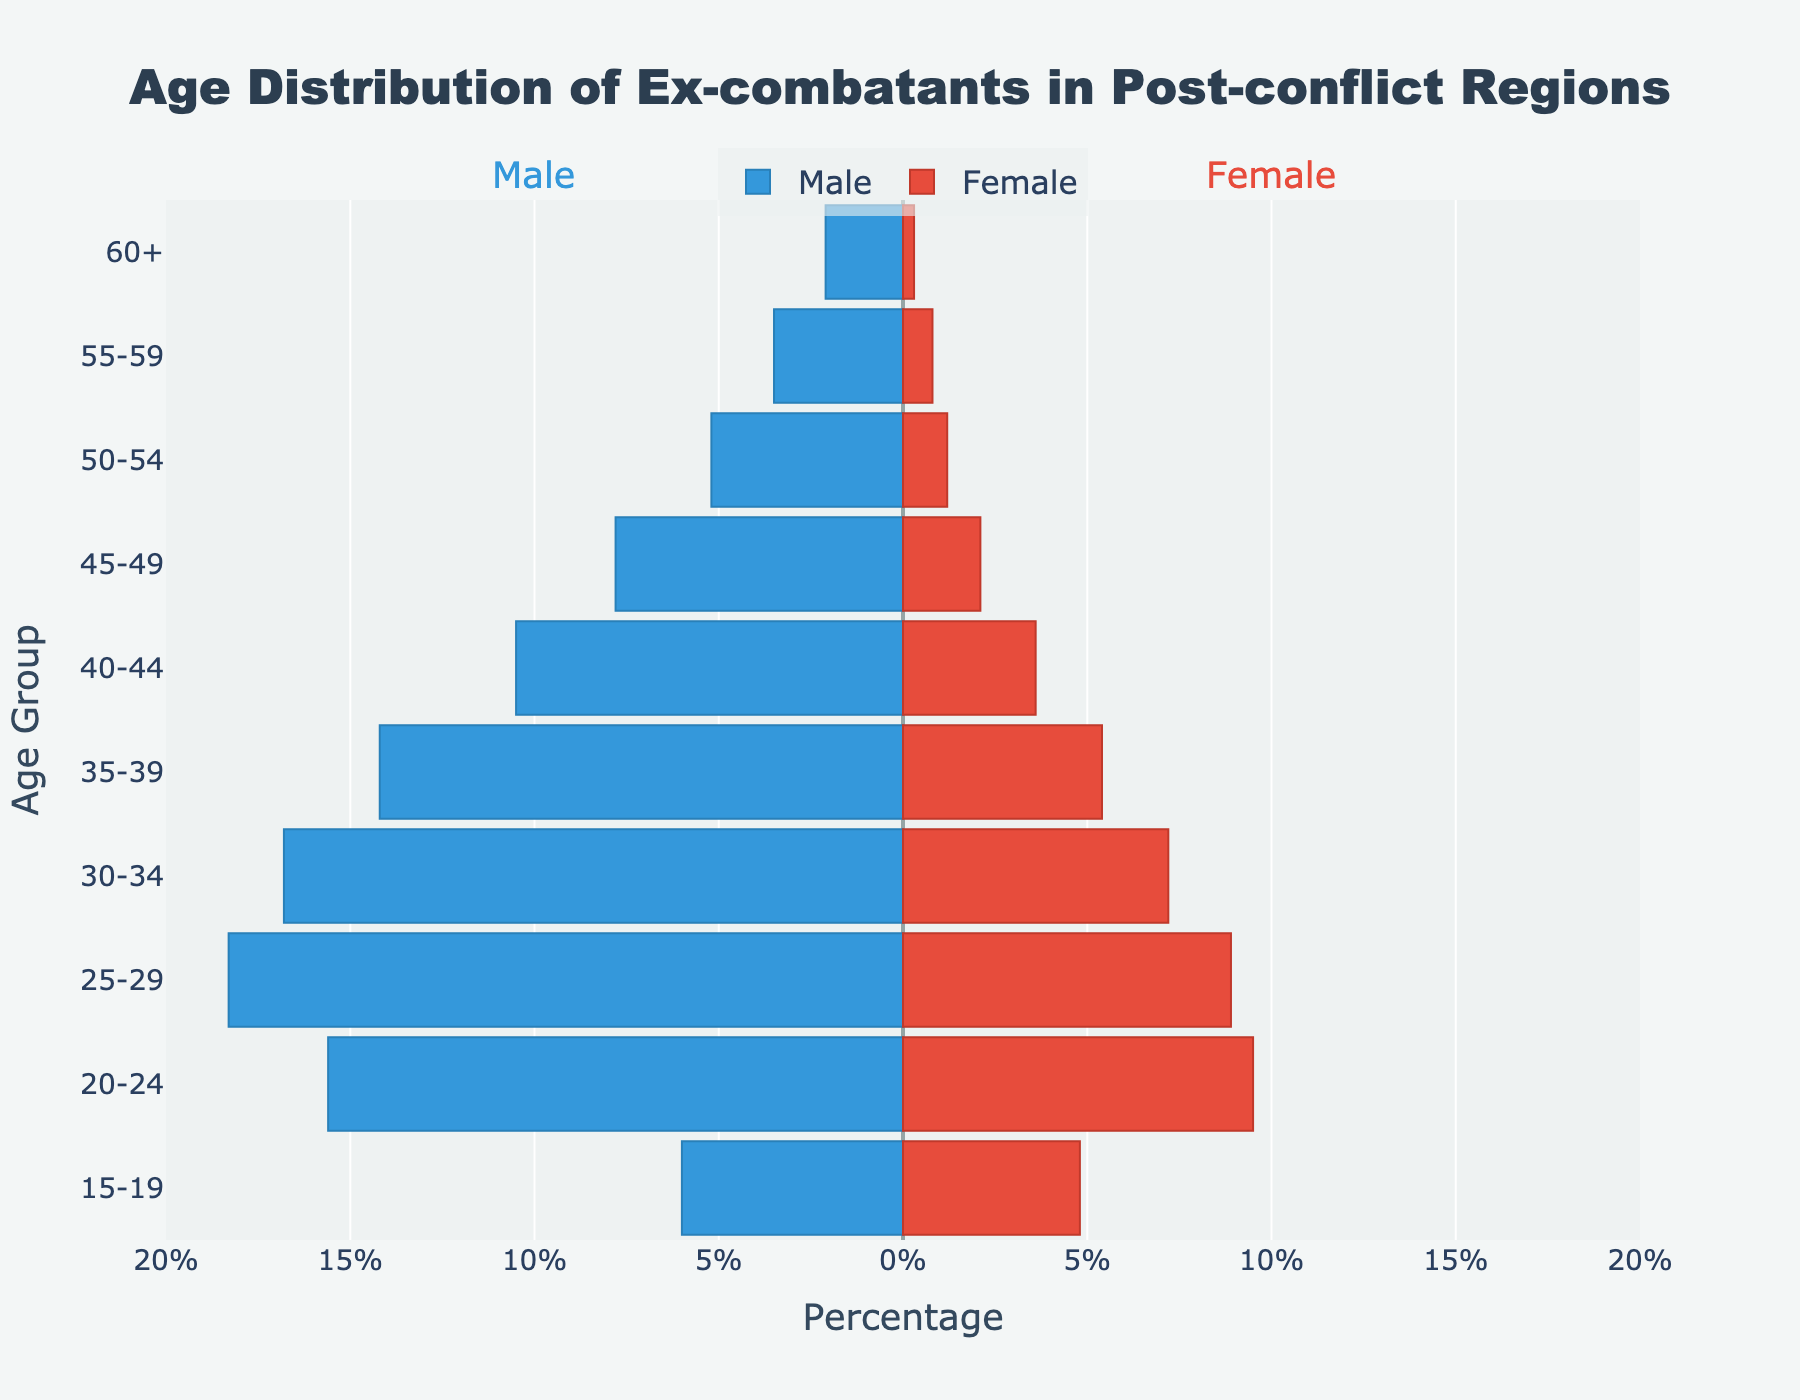what is the age group with the highest percentage of male ex-combatants? To find this, look at the male bars extending to the left. The longest bar represents the highest percentage. The age group 25-29 has the longest bar.
Answer: 25-29 what is the percentage of female ex-combatants in the age group 20-24? Look at the bar corresponding to the female ex-combatants for the age group 20-24. The value next to this bar is 9.5%.
Answer: 9.5% how does the percentage of male ex-combatants in the age group 40-44 compare to the percentage in the age group 30-34? Compare the length of the male bars for the age groups 40-44 and 30-34. The 40-44 age group has 10.5% while the 30-34 age group has 16.8%. The percentage is lower in the 40-44 age group.
Answer: lower in 40-44 which gender has a higher representation in the age group 55-59? Compare the lengths of the male and female bars for the age group 55-59. The male bar (3.5%) is longer than the female bar (0.8%). Therefore, males have a higher representation.
Answer: male what is the total percentage of ex-combatants (both male and female) in the age group 45-49? Add the male and female percentages within the age group 45-49. The male percentage is 7.8% and the female percentage is 2.1%. Therefore, the total is 7.8% + 2.1% = 9.9%.
Answer: 9.9% how does the percentage of female ex-combatants aged 30-34 compare to those aged 50-54? Compare the lengths of the female bars for age groups 30-34 and 50-54. The 30-34 age group has 7.2% and the 50-54 age group has 1.2%. So, the percentage is higher in the 30-34 age group.
Answer: higher in 30-34 which age group has the smallest difference in male and female percentages? Calculate the absolute differences between male and female percentages for each age group. The smallest difference is observed where the difference is minimal. Age group 20-24 has the smallest difference of 6.1% (15.6% - 9.5%).
Answer: 20-24 what is the total percentage of male ex-combatants aged 35-49? Add the male percentages for the age groups within the range 35-49, which are 35-39 (14.2%), 40-44 (10.5%), and 45-49 (7.8%). Therefore, the total is 14.2% + 10.5% + 7.8% = 32.5%.
Answer: 32.5% do both genders have the same percentage distribution in any age group? Check each age group's male and female bar lengths to see if any match. No age group has the same percentage for both genders.
Answer: no 